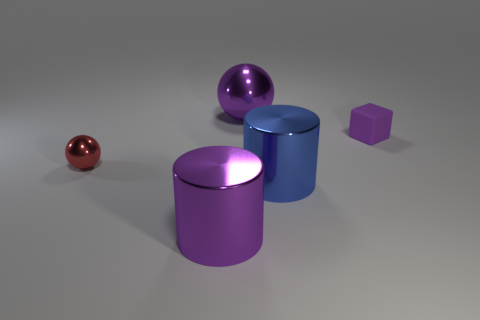Add 2 tiny metallic balls. How many objects exist? 7 Subtract all blocks. How many objects are left? 4 Subtract 0 blue balls. How many objects are left? 5 Subtract all spheres. Subtract all tiny red metallic spheres. How many objects are left? 2 Add 2 matte things. How many matte things are left? 3 Add 2 small purple matte blocks. How many small purple matte blocks exist? 3 